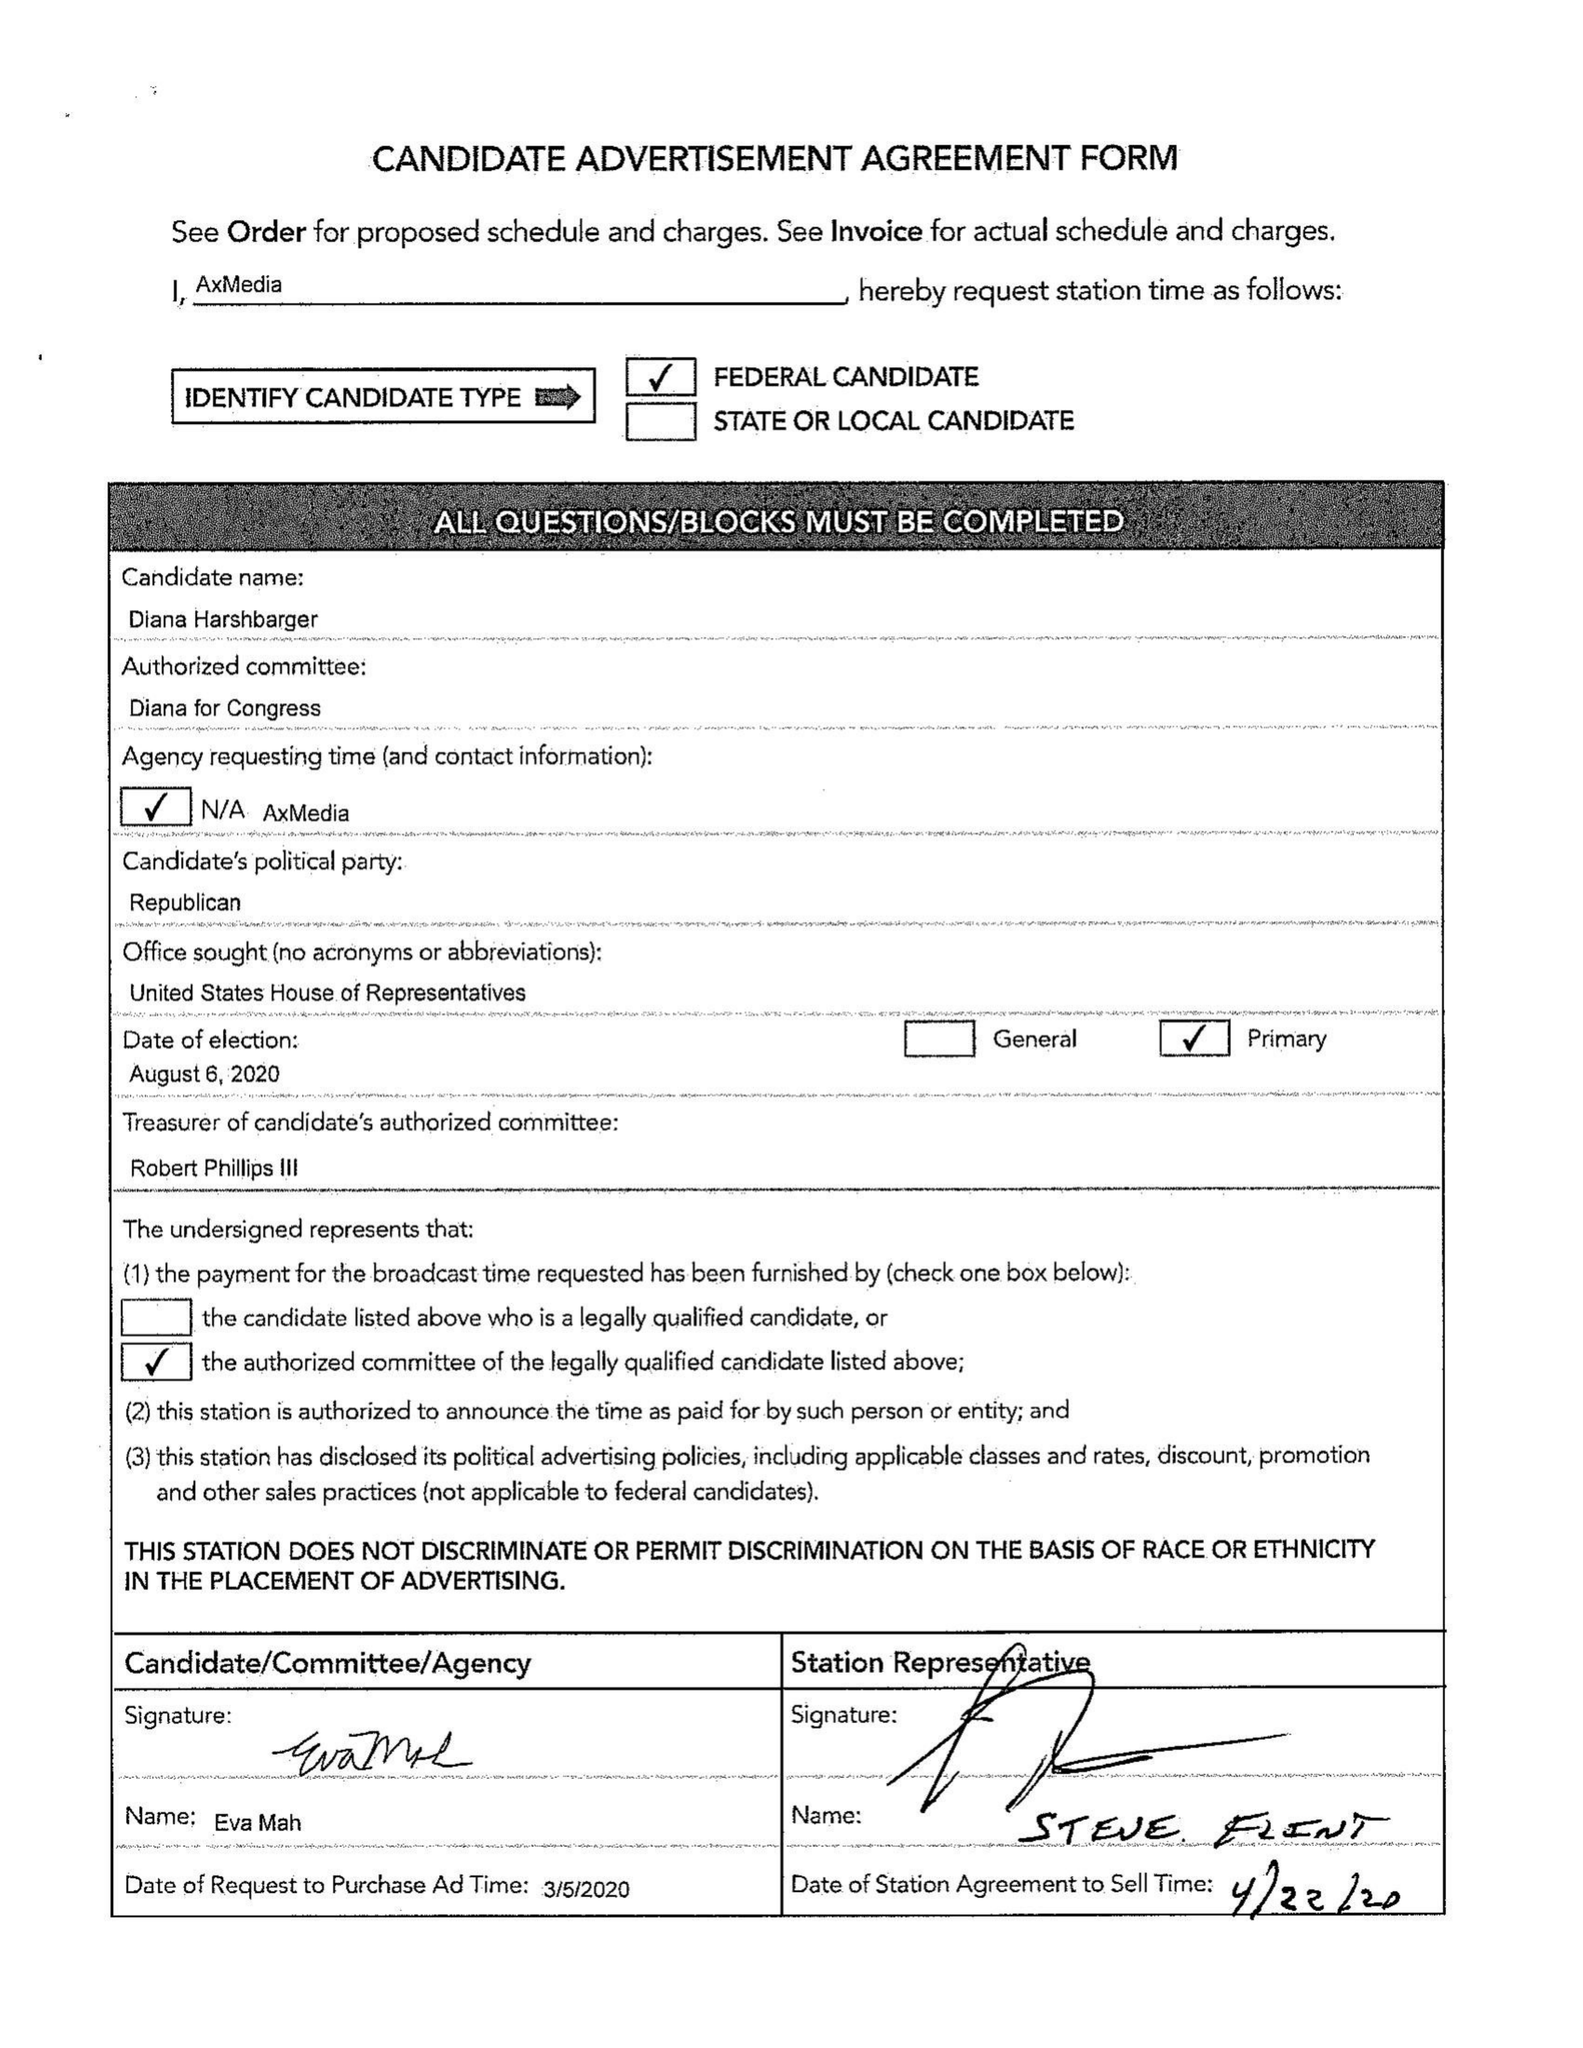What is the value for the contract_num?
Answer the question using a single word or phrase. 26892034 